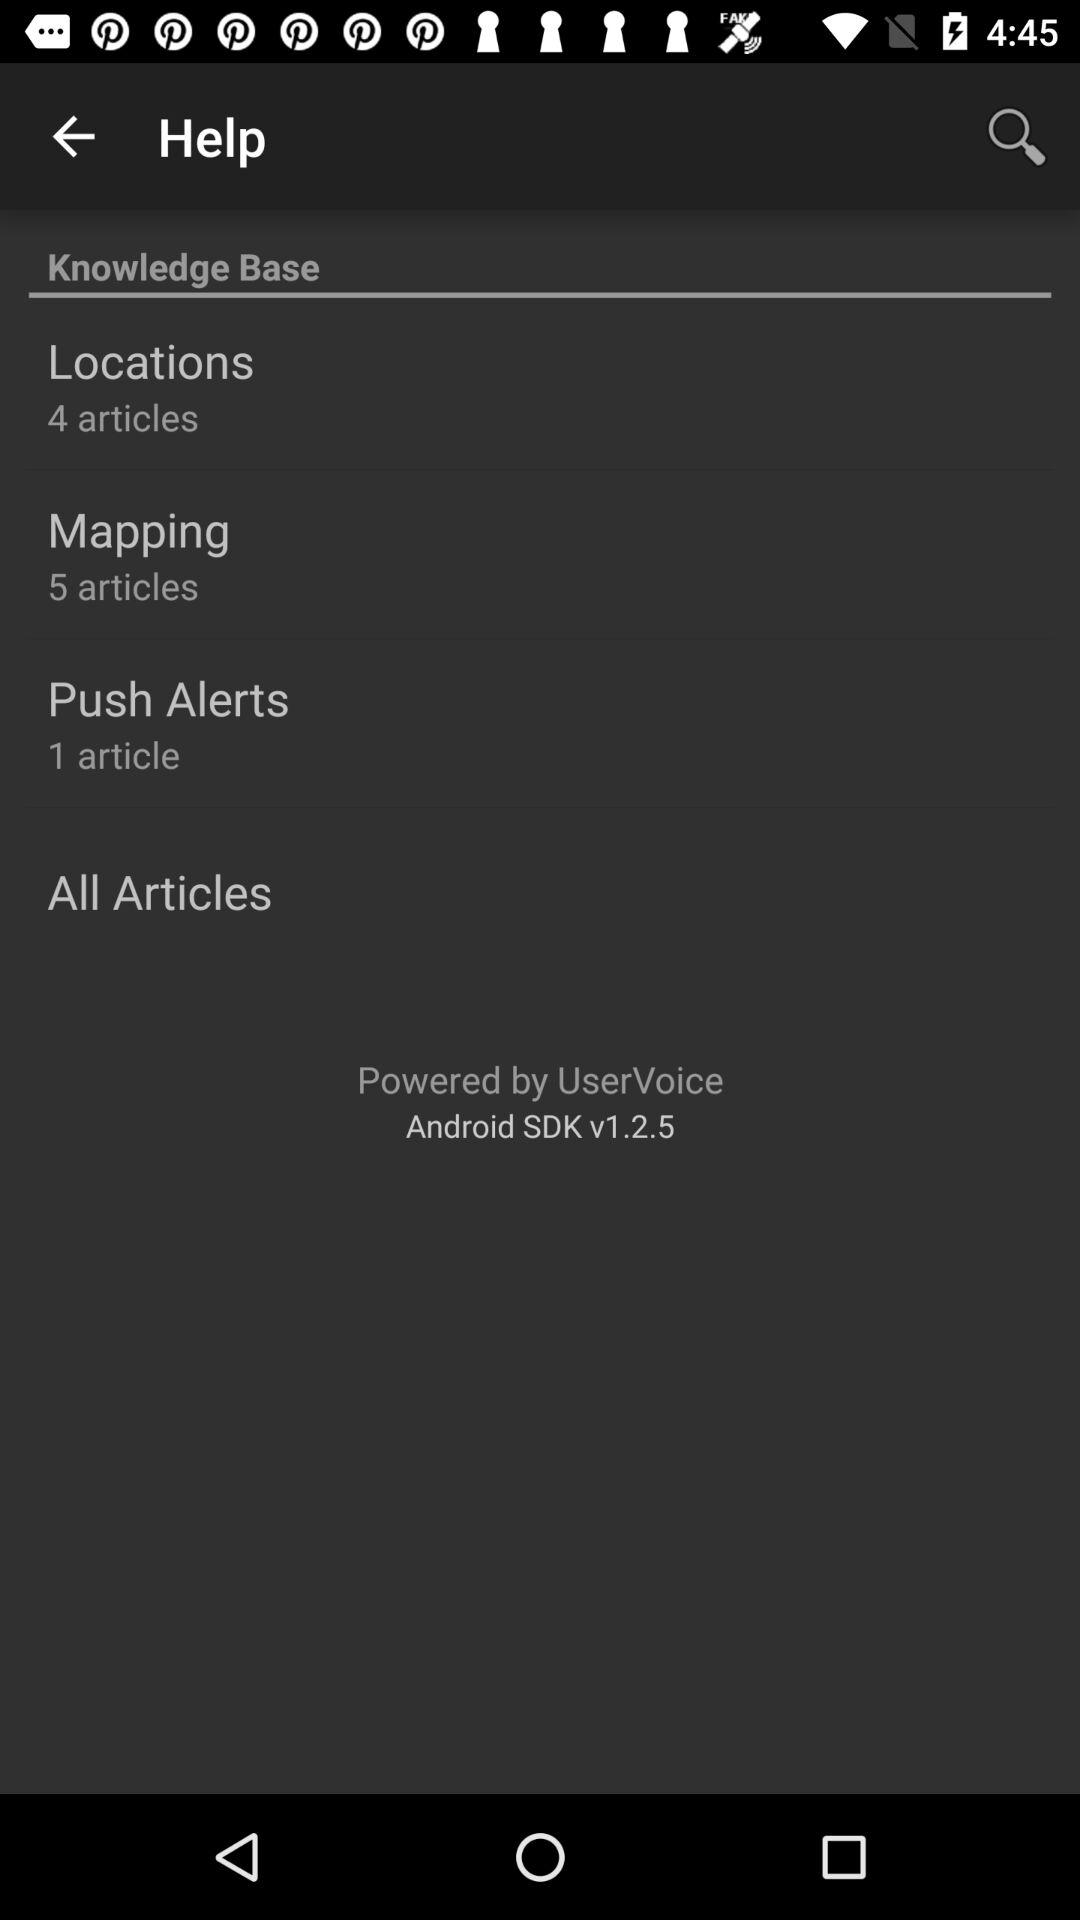How many articles are there in total?
Answer the question using a single word or phrase. 10 